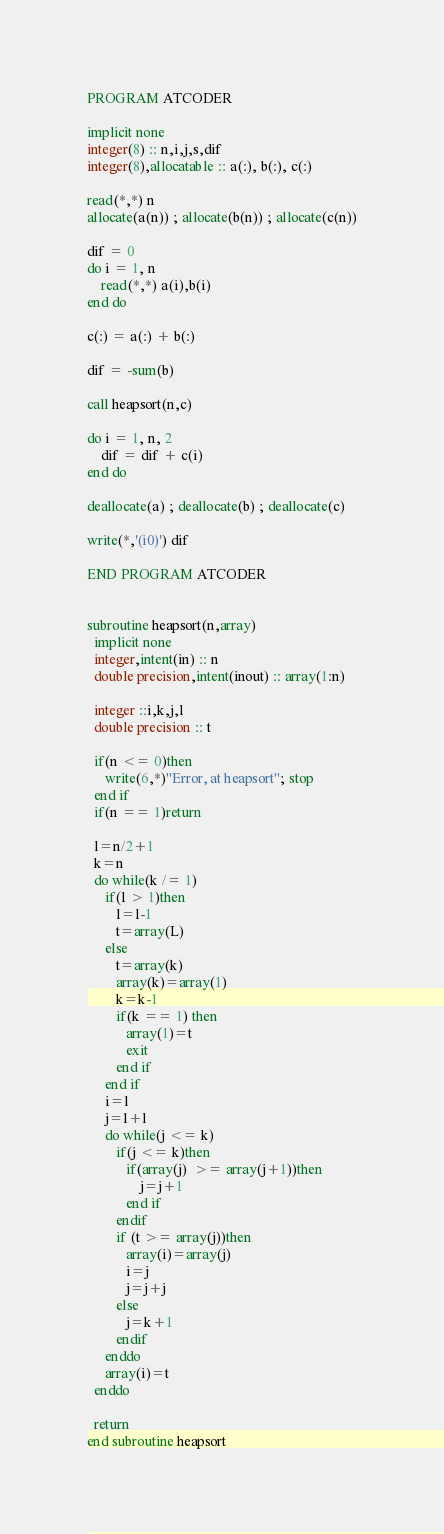Convert code to text. <code><loc_0><loc_0><loc_500><loc_500><_FORTRAN_>PROGRAM ATCODER

implicit none
integer(8) :: n,i,j,s,dif
integer(8),allocatable :: a(:), b(:), c(:)

read(*,*) n
allocate(a(n)) ; allocate(b(n)) ; allocate(c(n))

dif = 0
do i = 1, n
    read(*,*) a(i),b(i)
end do

c(:) = a(:) + b(:)

dif = -sum(b)

call heapsort(n,c)

do i = 1, n, 2
    dif = dif + c(i)
end do

deallocate(a) ; deallocate(b) ; deallocate(c)

write(*,'(i0)') dif

END PROGRAM ATCODER


subroutine heapsort(n,array)
  implicit none
  integer,intent(in) :: n
  double precision,intent(inout) :: array(1:n)
  
  integer ::i,k,j,l
  double precision :: t
  
  if(n <= 0)then
     write(6,*)"Error, at heapsort"; stop
  end if
  if(n == 1)return

  l=n/2+1
  k=n
  do while(k /= 1)
     if(l > 1)then
        l=l-1
        t=array(L)
     else
        t=array(k)
        array(k)=array(1)
        k=k-1
        if(k == 1) then
           array(1)=t
           exit
        end if
     end if
     i=l
     j=l+l
     do while(j <= k)
        if(j <= k)then
           if(array(j)  >= array(j+1))then
               j=j+1
           end if
        endif
        if (t >= array(j))then
           array(i)=array(j)
           i=j
           j=j+j
        else
           j=k+1
        endif
     enddo
     array(i)=t
  enddo

  return
end subroutine heapsort</code> 